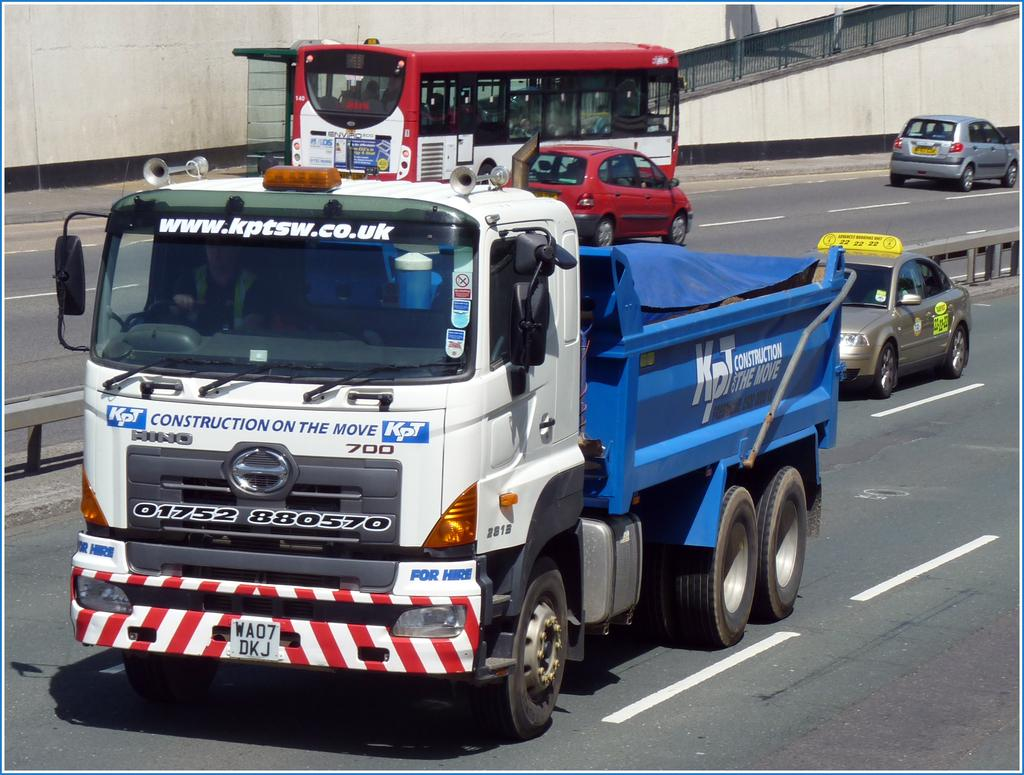<image>
Provide a brief description of the given image. The Hino truck is hauling a blue dumpster. 